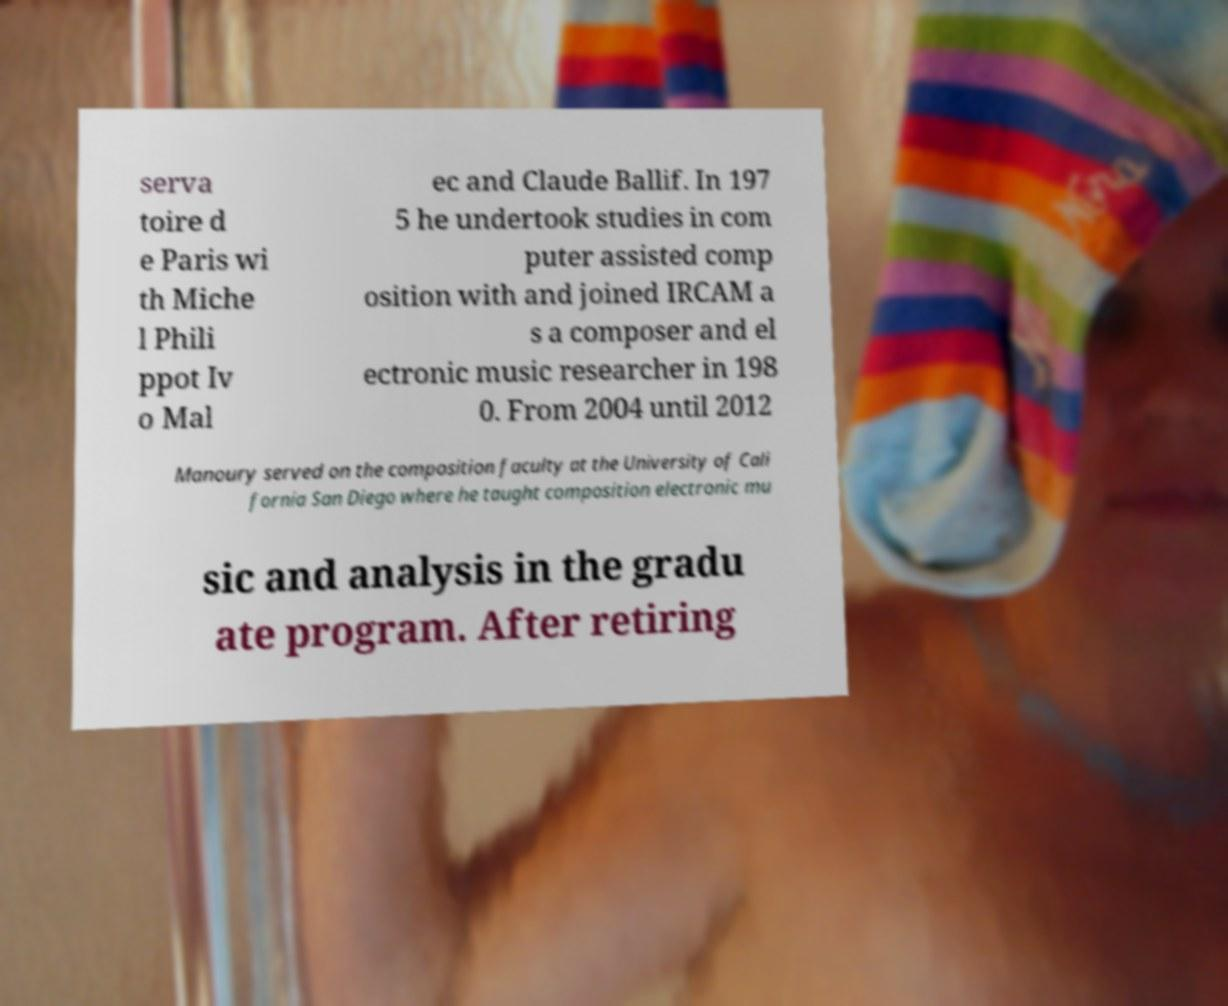Could you extract and type out the text from this image? serva toire d e Paris wi th Miche l Phili ppot Iv o Mal ec and Claude Ballif. In 197 5 he undertook studies in com puter assisted comp osition with and joined IRCAM a s a composer and el ectronic music researcher in 198 0. From 2004 until 2012 Manoury served on the composition faculty at the University of Cali fornia San Diego where he taught composition electronic mu sic and analysis in the gradu ate program. After retiring 